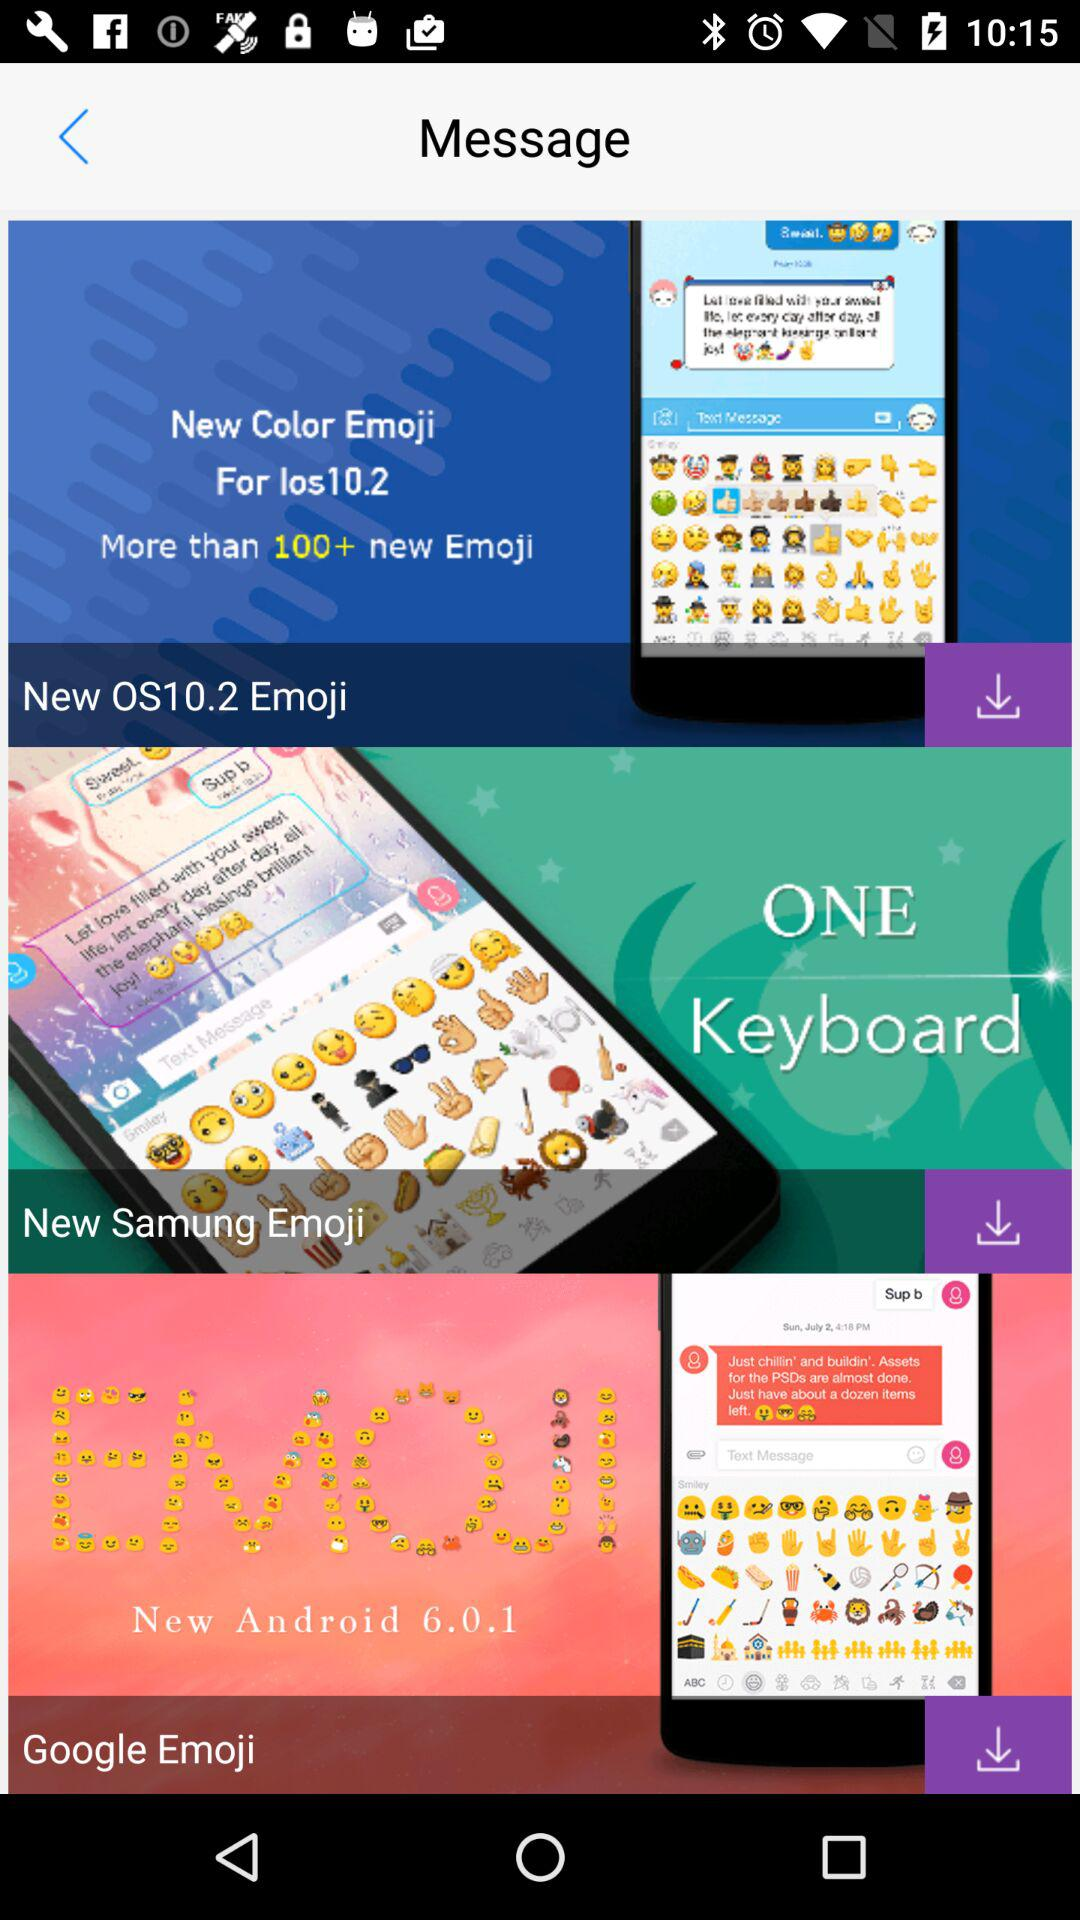What is the new OS number? The new OS number is 10.2. 